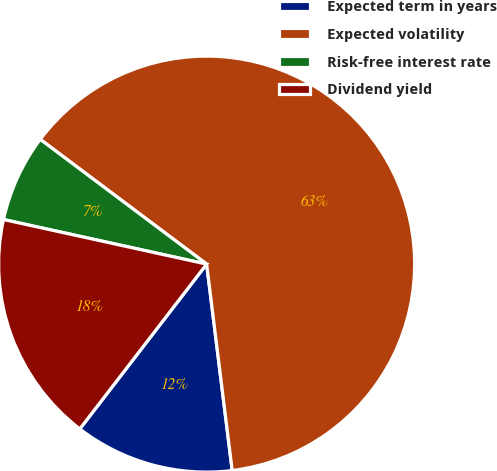Convert chart. <chart><loc_0><loc_0><loc_500><loc_500><pie_chart><fcel>Expected term in years<fcel>Expected volatility<fcel>Risk-free interest rate<fcel>Dividend yield<nl><fcel>12.4%<fcel>62.8%<fcel>6.8%<fcel>18.0%<nl></chart> 